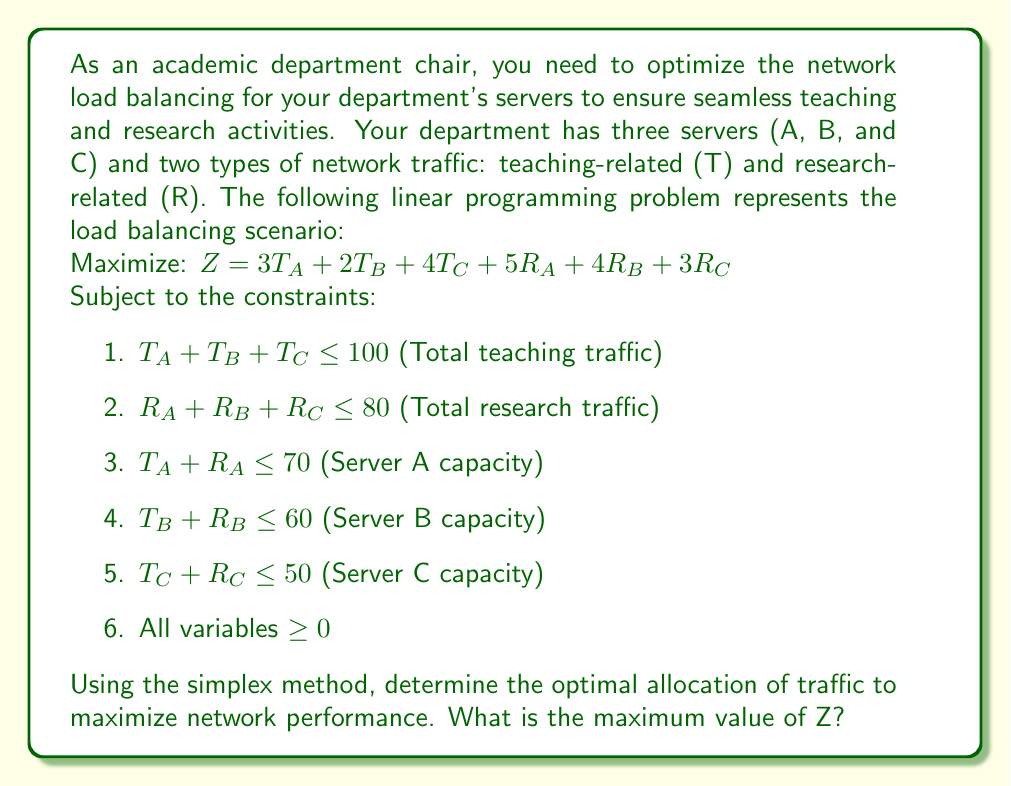Help me with this question. To solve this linear programming problem using the simplex method, we'll follow these steps:

1. Convert the problem to standard form by adding slack variables:
   $Z = 3T_A + 2T_B + 4T_C + 5R_A + 4R_B + 3R_C + 0S_1 + 0S_2 + 0S_3 + 0S_4 + 0S_5$
   
   Subject to:
   $T_A + T_B + T_C + S_1 = 100$
   $R_A + R_B + R_C + S_2 = 80$
   $T_A + R_A + S_3 = 70$
   $T_B + R_B + S_4 = 60$
   $T_C + R_C + S_5 = 50$

2. Set up the initial simplex tableau:

   $$
   \begin{array}{c|cccccccccccc|c}
    & T_A & T_B & T_C & R_A & R_B & R_C & S_1 & S_2 & S_3 & S_4 & S_5 & Z & RHS \\
   \hline
   S_1 & 1 & 1 & 1 & 0 & 0 & 0 & 1 & 0 & 0 & 0 & 0 & 0 & 100 \\
   S_2 & 0 & 0 & 0 & 1 & 1 & 1 & 0 & 1 & 0 & 0 & 0 & 0 & 80 \\
   S_3 & 1 & 0 & 0 & 1 & 0 & 0 & 0 & 0 & 1 & 0 & 0 & 0 & 70 \\
   S_4 & 0 & 1 & 0 & 0 & 1 & 0 & 0 & 0 & 0 & 1 & 0 & 0 & 60 \\
   S_5 & 0 & 0 & 1 & 0 & 0 & 1 & 0 & 0 & 0 & 0 & 1 & 0 & 50 \\
   \hline
   Z & -3 & -2 & -4 & -5 & -4 & -3 & 0 & 0 & 0 & 0 & 0 & 1 & 0
   \end{array}
   $$

3. Identify the pivot column (most negative in Z row): $R_A$ (-5)

4. Calculate the ratios and identify the pivot row:
   $S_1: 100 / 0 = \infty$
   $S_2: 80 / 1 = 80$
   $S_3: 70 / 1 = 70$ (pivot row)
   $S_4: 60 / 0 = \infty$
   $S_5: 50 / 0 = \infty$

5. Perform row operations to get the new tableau. Repeat steps 3-5 until no negative values remain in the Z row.

After several iterations, we reach the optimal solution:

$$
\begin{array}{c|cccccccccccc|c}
 & T_A & T_B & T_C & R_A & R_B & R_C & S_1 & S_2 & S_3 & S_4 & S_5 & Z & RHS \\
\hline
T_C & 0 & 0 & 1 & 0 & 0 & 0 & 1 & 0 & -1 & 0 & 0 & 0 & 30 \\
R_A & 0 & 0 & 0 & 1 & 0 & 0 & 0 & 1 & -1 & 0 & 0 & 0 & 40 \\
T_A & 1 & 0 & 0 & 0 & 0 & 0 & 0 & -1 & 2 & 0 & 0 & 0 & 30 \\
R_B & 0 & 0 & 0 & 0 & 1 & 0 & 0 & 0 & -1 & 1 & 0 & 0 & 40 \\
R_C & 0 & 0 & 0 & 0 & 0 & 1 & -1 & 0 & 1 & 0 & 1 & 0 & 20 \\
\hline
Z & 0 & -2 & 0 & 0 & 0 & 0 & 1 & 1 & 2 & 0 & 0 & 1 & 520
\end{array}
$$

The optimal solution is:
$T_A = 30, T_B = 0, T_C = 30, R_A = 40, R_B = 40, R_C = 20$

The maximum value of Z is 520.
Answer: The maximum value of Z is 520, achieved with the following traffic allocation:
$T_A = 30, T_B = 0, T_C = 30, R_A = 40, R_B = 40, R_C = 20$ 